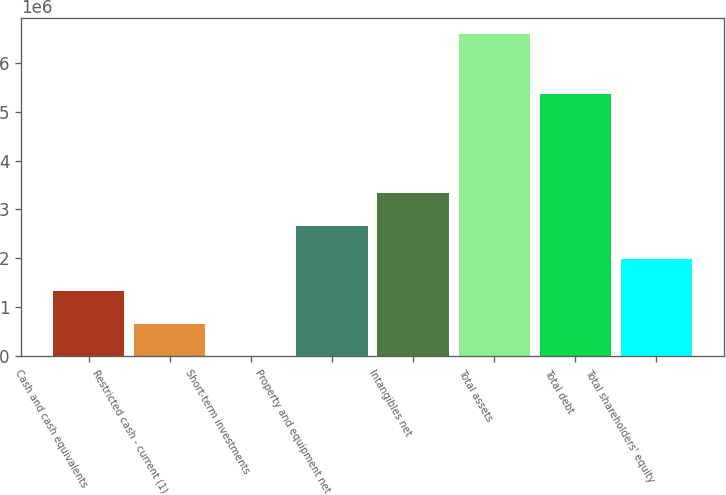Convert chart to OTSL. <chart><loc_0><loc_0><loc_500><loc_500><bar_chart><fcel>Cash and cash equivalents<fcel>Restricted cash - current (1)<fcel>Short-term investments<fcel>Property and equipment net<fcel>Intangibles net<fcel>Total assets<fcel>Total debt<fcel>Total shareholders' equity<nl><fcel>1.3235e+06<fcel>664486<fcel>5471<fcel>2.67132e+06<fcel>3.33033e+06<fcel>6.59562e+06<fcel>5.3561e+06<fcel>1.98251e+06<nl></chart> 